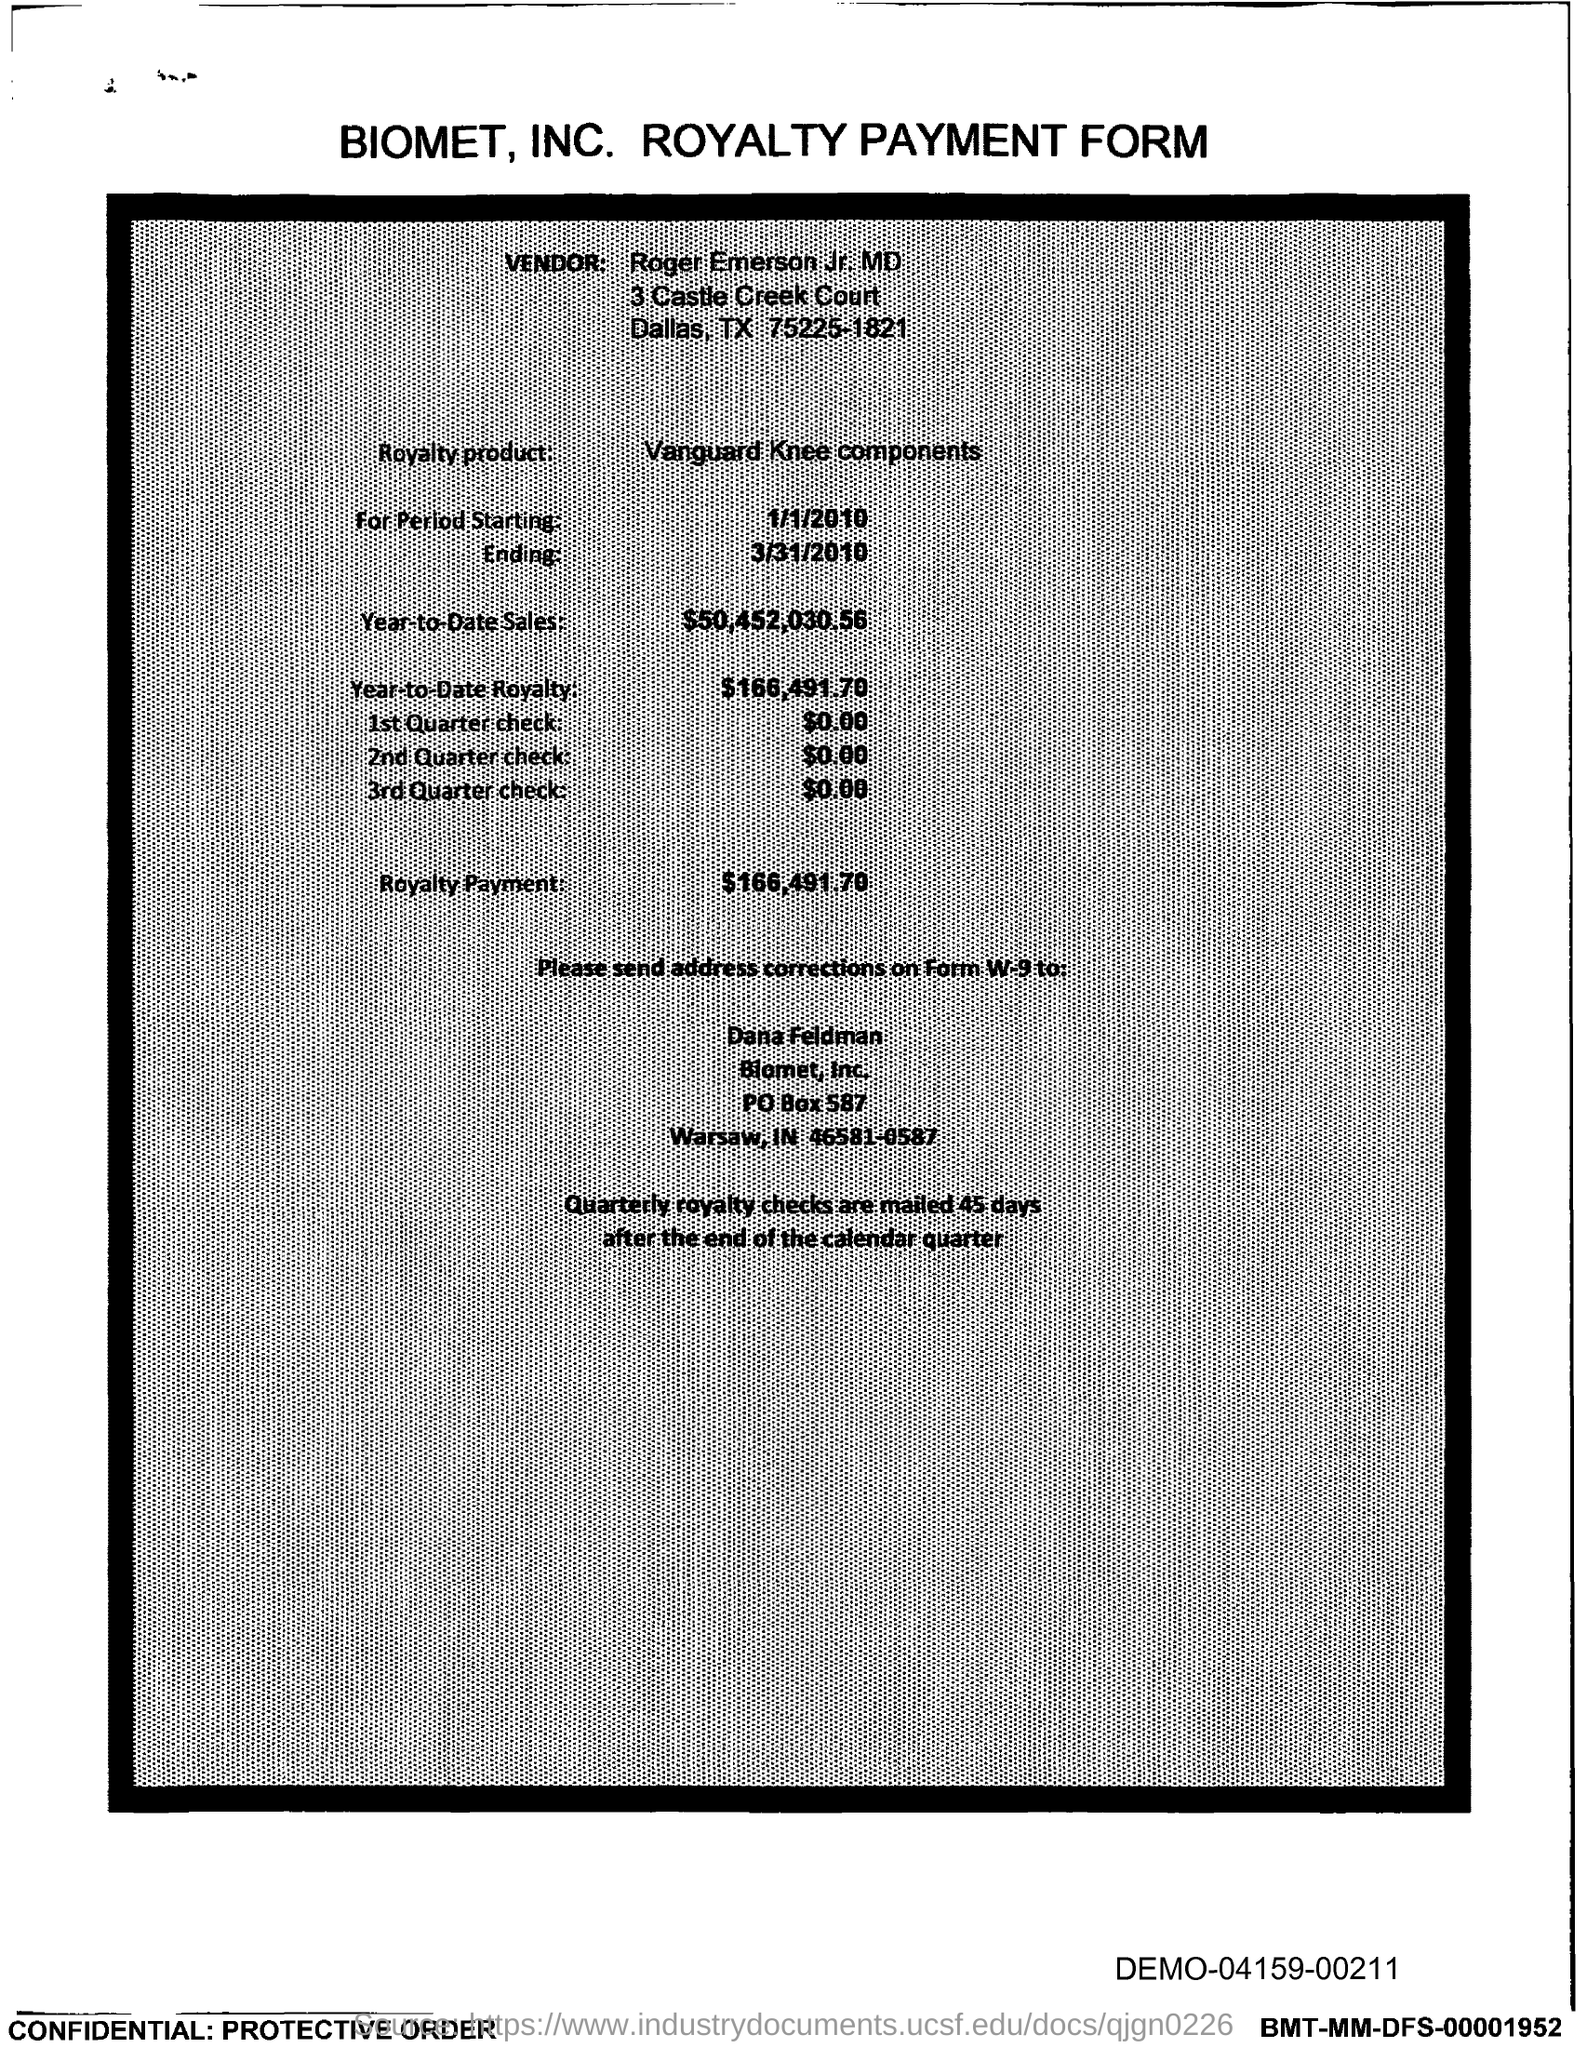In which state is biomet, inc. located ?
Provide a succinct answer. IN. What is the po box no. of biomet, inc.?
Keep it short and to the point. 587. What is the royalty product name ?
Your response must be concise. Vanguard Knee components. What is the year-to-date sales?
Give a very brief answer. $50,452,030.56. What is the year-to-date royalty ?
Your answer should be very brief. $166,491.70. What is the royalty payment ?
Provide a short and direct response. $166,491.70. 